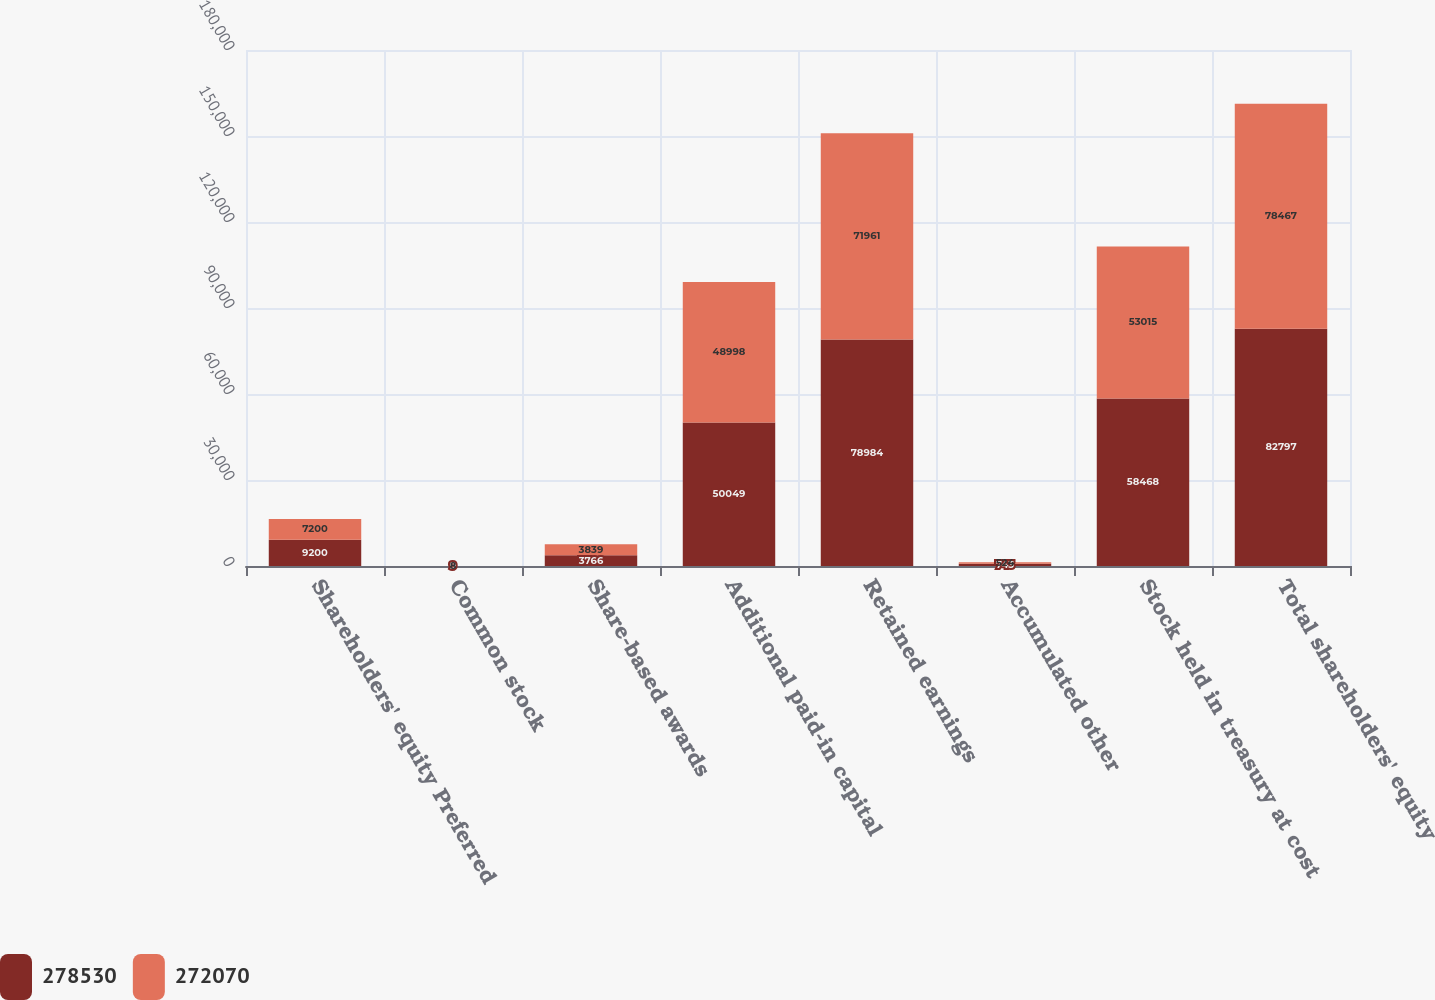Convert chart. <chart><loc_0><loc_0><loc_500><loc_500><stacked_bar_chart><ecel><fcel>Shareholders' equity Preferred<fcel>Common stock<fcel>Share-based awards<fcel>Additional paid-in capital<fcel>Retained earnings<fcel>Accumulated other<fcel>Stock held in treasury at cost<fcel>Total shareholders' equity<nl><fcel>278530<fcel>9200<fcel>9<fcel>3766<fcel>50049<fcel>78984<fcel>743<fcel>58468<fcel>82797<nl><fcel>272070<fcel>7200<fcel>8<fcel>3839<fcel>48998<fcel>71961<fcel>524<fcel>53015<fcel>78467<nl></chart> 